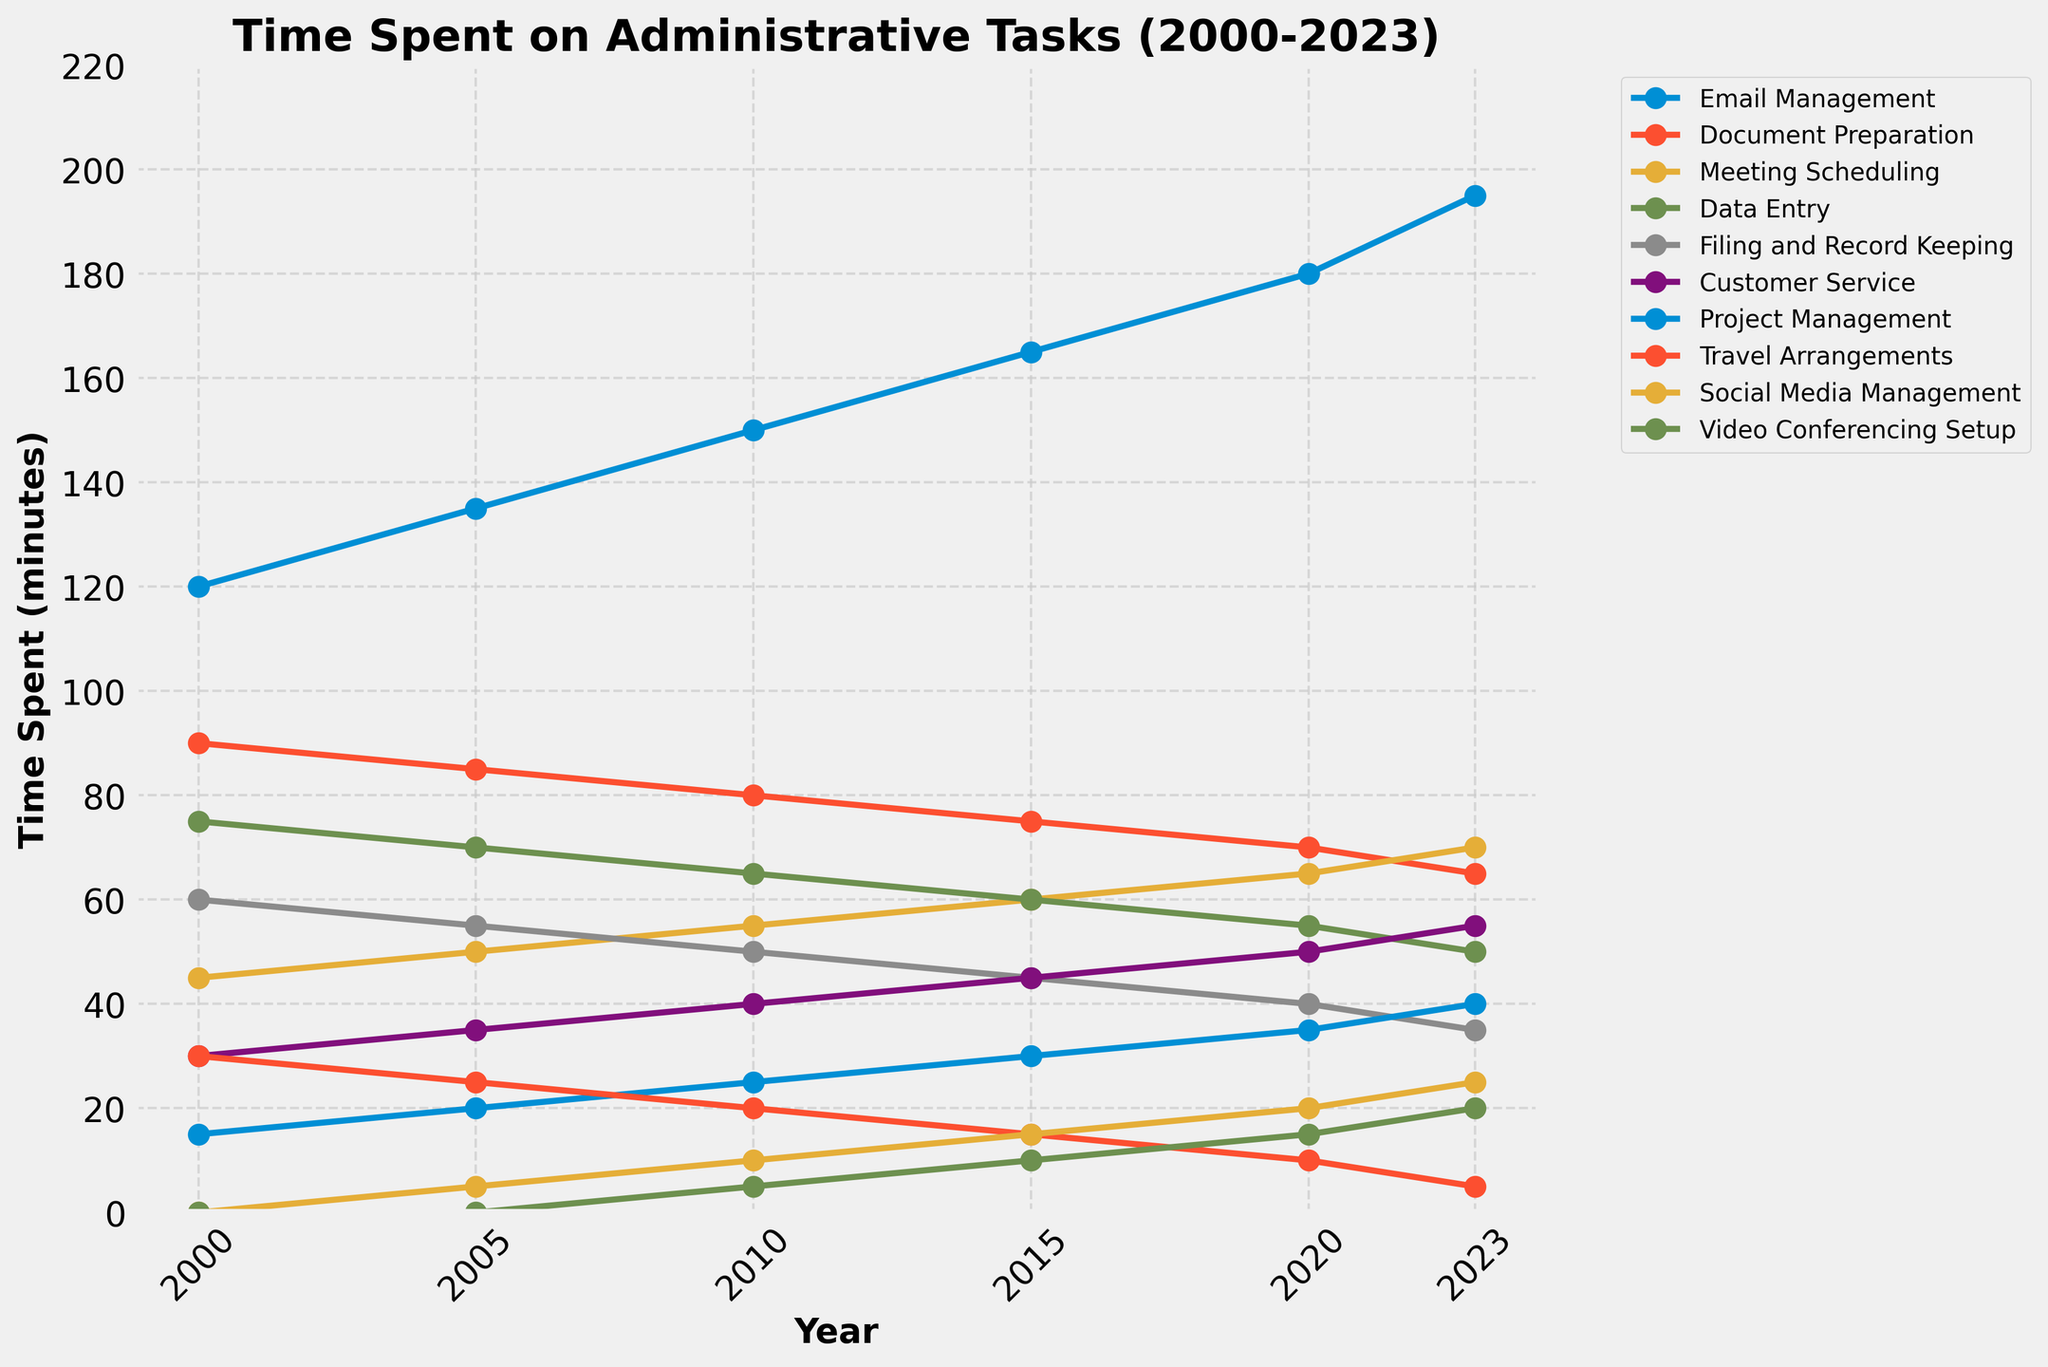How has the time spent on Email Management changed from 2000 to 2023? In the line chart, locate the data points for Email Management for 2000 and 2023. Note their values (120 minutes in 2000 and 195 minutes in 2023) and calculate the increase.
Answer: Increased by 75 minutes Which task saw the most significant decrease in time spent from 2000 to 2023? Identify each task's data points for 2000 and 2023, then calculate the difference. Travel Arrangements show the most significant decrease (from 30 minutes in 2000 to 5 minutes in 2023).
Answer: Travel Arrangements What is the average time spent on Document Preparation and Data Entry in 2023? Locate the 2023 data points for Document Preparation (65 minutes) and Data Entry (50 minutes). Sum these values and divide by 2 to find the average.
Answer: 57.5 minutes Is the time spent on Social Media Management greater than that on Filing and Record Keeping in 2023? Compare the data points for Social Media Management (25 minutes) and Filing and Record Keeping (35 minutes) for 2023.
Answer: No Which task's time followed an entirely increasing trend from 2000 to 2023? Review the trends of each task. Email Management and Customer Service show an increasing trend, but the only task that increases every interval without any decrease is Meeting Scheduling.
Answer: Meeting Scheduling Did Project Management see the same amount of time increase as Video Conferencing Setup from 2000 to 2023? Compare the 2000 and 2023 data points for both tasks. Project Management increases from 15 to 40 minutes (25 minutes increase), whereas Video Conferencing Setup increases from 0 to 20 minutes (20 minutes increase).
Answer: No How much more time was spent on Email Management compared to Social Media Management in 2020? Identify the 2020 data points for Email Management (180 minutes) and Social Media Management (20 minutes). Calculate the difference by subtracting the latter from the former.
Answer: 160 minutes What is the median time spent on tasks in 2023? Note down all time values for 2023: 195, 65, 70, 50, 35, 55, 40, 5, 25, 20. Sort these values and find the middle one (or the average of the two middle values). Sorted: 5, 20, 25, 35, 40, 50, 55, 65, 70, 195 (median is the average of 40 and 50).
Answer: 45 minutes 